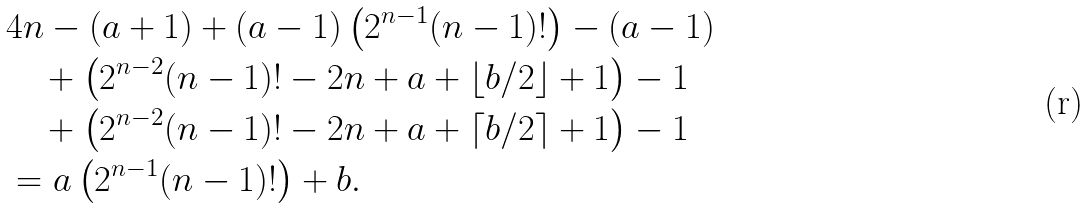Convert formula to latex. <formula><loc_0><loc_0><loc_500><loc_500>& 4 n - ( a + 1 ) + ( a - 1 ) \left ( 2 ^ { n - 1 } ( n - 1 ) ! \right ) - ( a - 1 ) \\ & \quad + \left ( 2 ^ { n - 2 } ( n - 1 ) ! - 2 n + a + \left \lfloor b / 2 \right \rfloor + 1 \right ) - 1 \\ & \quad + \left ( 2 ^ { n - 2 } ( n - 1 ) ! - 2 n + a + \left \lceil b / 2 \right \rceil + 1 \right ) - 1 \\ & = a \left ( 2 ^ { n - 1 } ( n - 1 ) ! \right ) + b .</formula> 